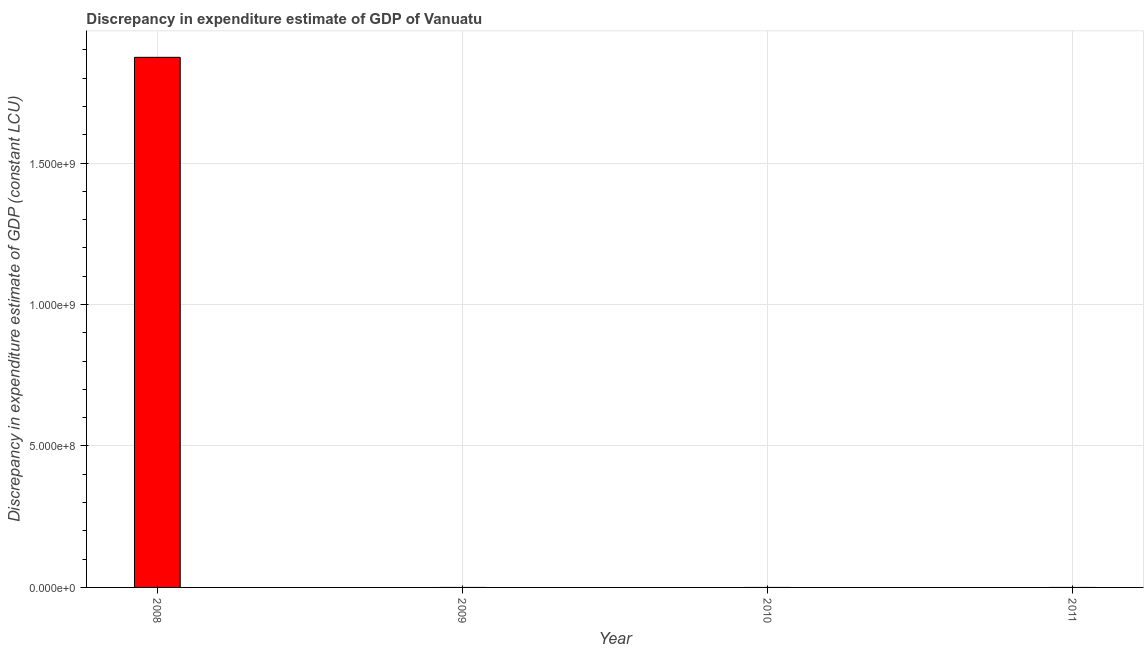Does the graph contain any zero values?
Your response must be concise. Yes. What is the title of the graph?
Your answer should be compact. Discrepancy in expenditure estimate of GDP of Vanuatu. What is the label or title of the Y-axis?
Make the answer very short. Discrepancy in expenditure estimate of GDP (constant LCU). Across all years, what is the maximum discrepancy in expenditure estimate of gdp?
Your response must be concise. 1.87e+09. Across all years, what is the minimum discrepancy in expenditure estimate of gdp?
Offer a very short reply. 0. In which year was the discrepancy in expenditure estimate of gdp maximum?
Provide a succinct answer. 2008. What is the sum of the discrepancy in expenditure estimate of gdp?
Keep it short and to the point. 1.87e+09. What is the average discrepancy in expenditure estimate of gdp per year?
Keep it short and to the point. 4.68e+08. What is the median discrepancy in expenditure estimate of gdp?
Your answer should be compact. 0. In how many years, is the discrepancy in expenditure estimate of gdp greater than 400000000 LCU?
Your answer should be very brief. 1. What is the difference between the highest and the lowest discrepancy in expenditure estimate of gdp?
Provide a short and direct response. 1.87e+09. Are all the bars in the graph horizontal?
Your response must be concise. No. What is the difference between two consecutive major ticks on the Y-axis?
Provide a short and direct response. 5.00e+08. Are the values on the major ticks of Y-axis written in scientific E-notation?
Provide a short and direct response. Yes. What is the Discrepancy in expenditure estimate of GDP (constant LCU) in 2008?
Keep it short and to the point. 1.87e+09. What is the Discrepancy in expenditure estimate of GDP (constant LCU) of 2009?
Keep it short and to the point. 0. What is the Discrepancy in expenditure estimate of GDP (constant LCU) of 2010?
Give a very brief answer. 0. What is the Discrepancy in expenditure estimate of GDP (constant LCU) in 2011?
Make the answer very short. 0. 